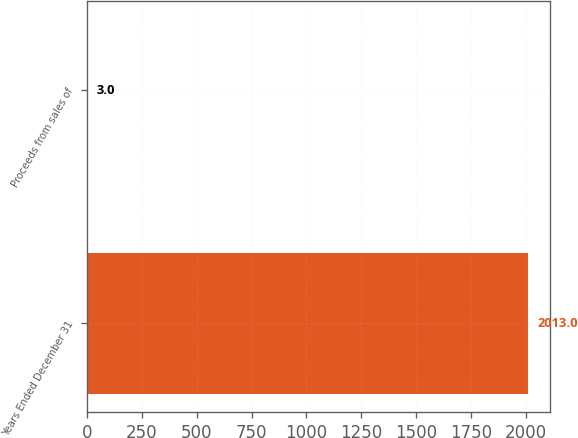<chart> <loc_0><loc_0><loc_500><loc_500><bar_chart><fcel>Years Ended December 31<fcel>Proceeds from sales of<nl><fcel>2013<fcel>3<nl></chart> 